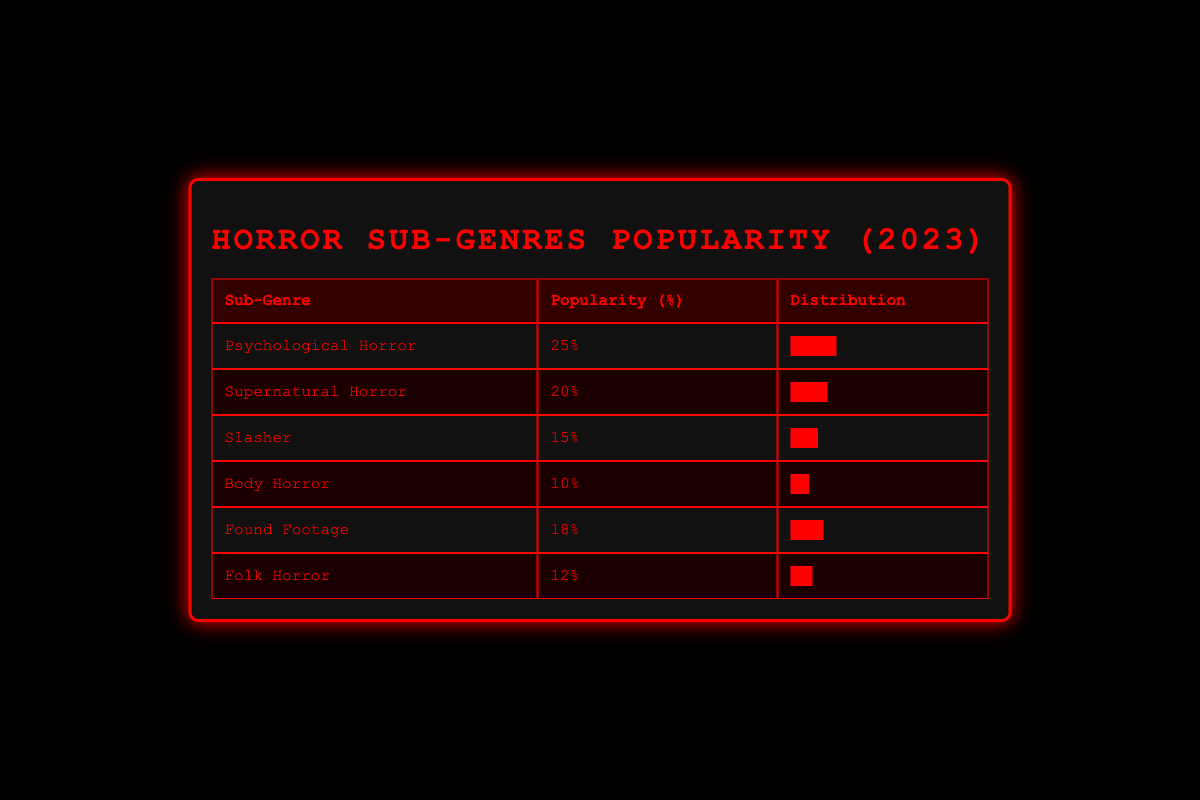What is the most popular horror sub-genre in 2023? The table shows the popularity of each horror sub-genre as a percentage. The highest percentage is 25% for "Psychological Horror," making it the most popular sub-genre.
Answer: Psychological Horror Which sub-genre has a popularity percentage of 15%? By checking the popularity column in the table, we can see that the sub-genre with a 15% popularity is "Slasher."
Answer: Slasher What is the difference in popularity between Supernatural Horror and Body Horror? The popularity of "Supernatural Horror" is 20%, and "Body Horror" is 10%. To find the difference, we subtract: 20% - 10% = 10%.
Answer: 10% Is Folk Horror more popular than Found Footage? Checking the popularity percentages, "Folk Horror" has 12% while "Found Footage" has 18%. Since 12% is less than 18%, Folk Horror is not more popular.
Answer: No What is the average popularity of the horror sub-genres listed? To find the average, we sum the popularity percentages: 25 + 20 + 15 + 10 + 18 + 12 = 110. There are 6 sub-genres, so we divide the total by 6: 110 / 6 = 18.33%.
Answer: 18.33% 